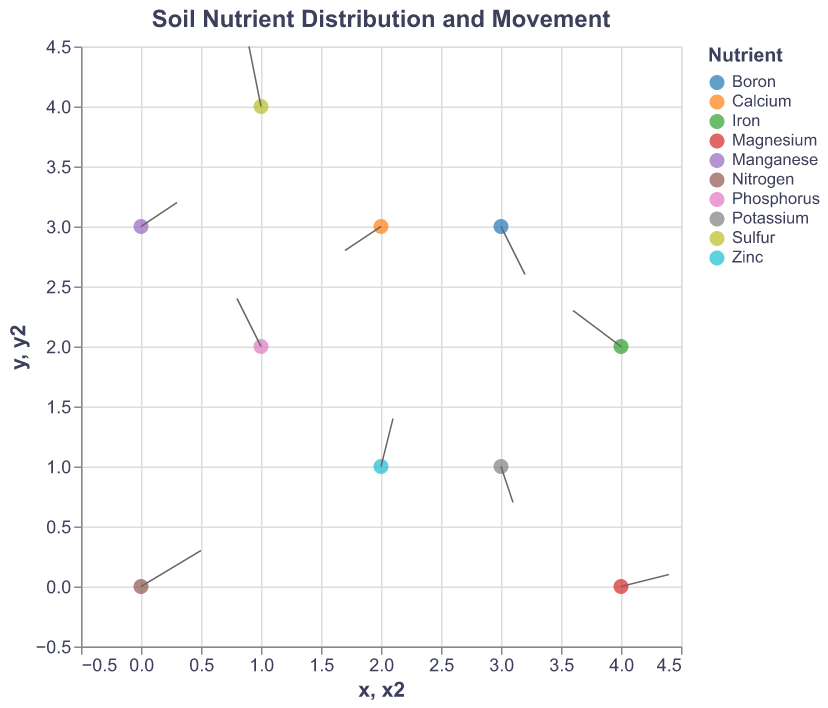How many data points are shown in the figure? Count each point using its (x, y) position on the plot. There are ten points in total from the data provided.
Answer: 10 What does the color of each point represent on the plot? Each point's color represents a different nutrient type, such as Nitrogen, Phosphorus, or Potassium.
Answer: Nutrient type Which nutrient shows the most upward (positive y) movement, and what is its exact movement? Look at the data values for 'v' to see which is the highest positive. For Sulfur at (1, 4), the value of 'v' is 0.5, which is the highest positive upward movement shown in the figure.
Answer: Sulfur, 0.5 What is the nutrient distribution at position (2, 1), and in which direction is it moving? Check the x=2 and y=1 coordinates in the data. The nutrient at (2, 1) is Zinc, and it is moving right (u=0.1) and upward (v=0.4).
Answer: Zinc, right and upward Which nutrient is moving further down both horizontally and vertically? Look for the smallest negative values for both 'u' and 'v'. Calcium at (2, 3) has u=-0.3 and v=-0.2, making it the nutrient moving further down in both directions.
Answer: Calcium What's the average horizontal movement (u-direction) of all nutrients? Sum all 'u' values and divide by the number of data points: (0.5 - 0.2 + 0.1 - 0.3 + 0.4 - 0.1 + 0.2 + 0.3 - 0.4 + 0.1) / 10 = 0.6 / 10 = 0.06.
Answer: 0.06 Describe the movement of Nitrogen in terms of direction and magnitude. Nitrogen is at (0, 0) with 'u'=0.5 and 'v'=0.3, so it moves right and up. The magnitude is calculated as sqrt(0.5^2 + 0.3^2) ≈ 0.58.
Answer: Right and up, 0.58 Which nutrient shows the greatest overall movement distance? Calculate the distance for each nutrient: sqrt(u^2 + v^2). Sulfur (at 1, 4) has (u=-0.1, v=0.5): magnitude = sqrt(0.01 + 0.25) = 0.51. This is the largest distance in the data provided.
Answer: Sulfur Identify the nutrient that moves leftward the most and mention its coordinates. Look for the most negative 'u' value. Iron (at 4, 2) has the most leftward movement with u=-0.4. The coordinates are (4, 2).
Answer: Iron, (4, 2) 